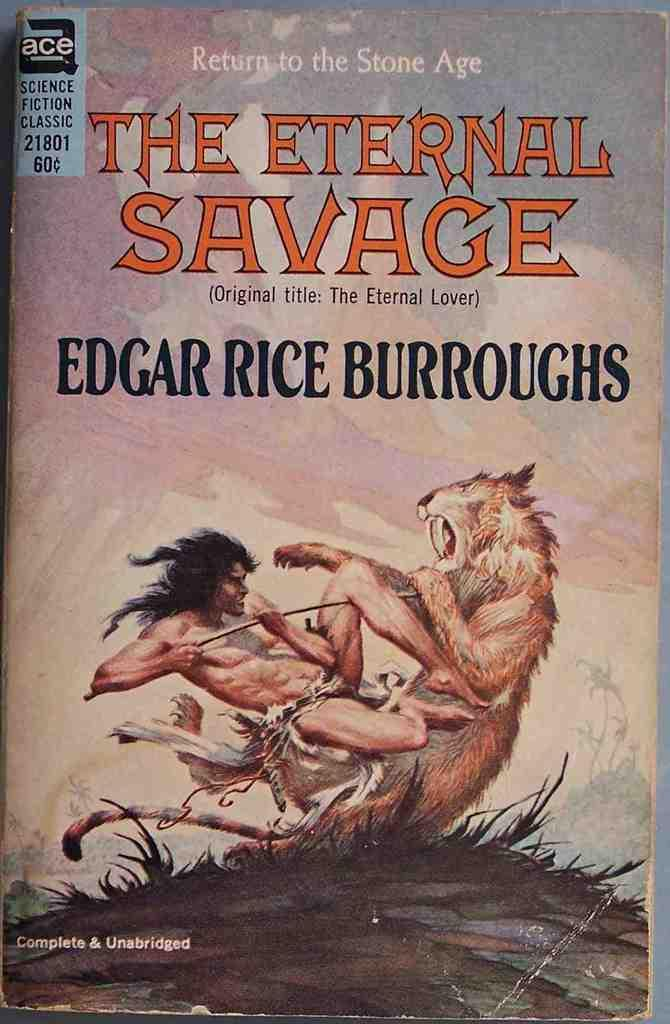<image>
Give a short and clear explanation of the subsequent image. A book called "The Eternal Savage" by Edgar Rice Burroughs is shown with a man fighting a beast on its cover. 